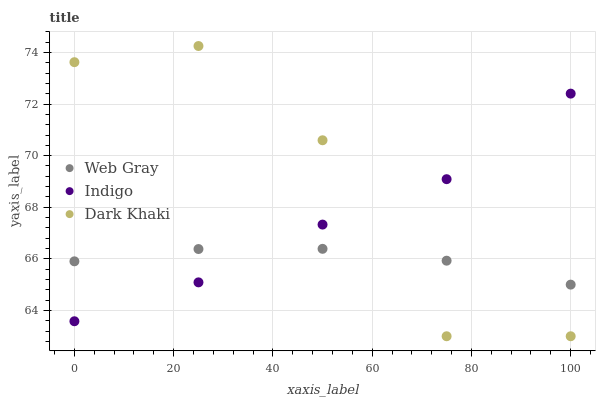Does Web Gray have the minimum area under the curve?
Answer yes or no. Yes. Does Dark Khaki have the maximum area under the curve?
Answer yes or no. Yes. Does Indigo have the minimum area under the curve?
Answer yes or no. No. Does Indigo have the maximum area under the curve?
Answer yes or no. No. Is Web Gray the smoothest?
Answer yes or no. Yes. Is Dark Khaki the roughest?
Answer yes or no. Yes. Is Indigo the smoothest?
Answer yes or no. No. Is Indigo the roughest?
Answer yes or no. No. Does Dark Khaki have the lowest value?
Answer yes or no. Yes. Does Indigo have the lowest value?
Answer yes or no. No. Does Dark Khaki have the highest value?
Answer yes or no. Yes. Does Indigo have the highest value?
Answer yes or no. No. Does Dark Khaki intersect Web Gray?
Answer yes or no. Yes. Is Dark Khaki less than Web Gray?
Answer yes or no. No. Is Dark Khaki greater than Web Gray?
Answer yes or no. No. 